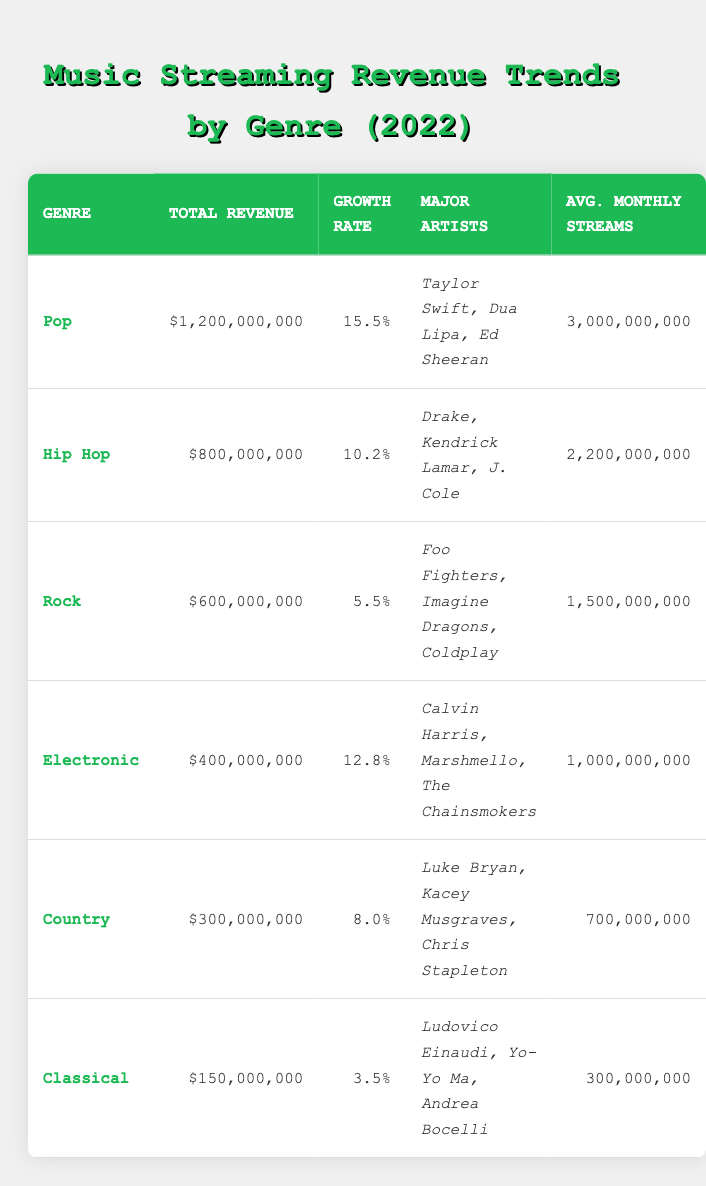What is the total revenue for the Pop genre in 2022? According to the table, the total revenue for the Pop genre is specifically listed as $1,200,000,000.
Answer: $1,200,000,000 Which genre experienced the highest growth rate? The table shows the growth rates for each genre, and Pop has the highest growth rate at 15.5%.
Answer: Pop What is the average monthly streams for the Rock genre? The average monthly streams for the Rock genre, as indicated in the table, is 1,500,000,000.
Answer: 1,500,000,000 What is the total revenue across all genres in 2022? To find the total revenue, we sum the revenues for all listed genres: 1,200,000,000 (Pop) + 800,000,000 (Hip Hop) + 600,000,000 (Rock) + 400,000,000 (Electronic) + 300,000,000 (Country) + 150,000,000 (Classical) = 3,450,000,000.
Answer: $3,450,000,000 Is the growth rate for Electronic music greater than that for Country music? The growth rate for Electronic music is 12.8%, while the growth rate for Country music is 8.0%. Since 12.8% is greater than 8.0%, the statement is true.
Answer: Yes Are the average monthly streams for Classical music higher than for Hip Hop? The average monthly streams for Classical music is 300,000,000, while for Hip Hop it is 2,200,000,000. Since 300,000,000 is not higher, the statement is false.
Answer: No What is the total revenue for genres that have a growth rate of over 10%? The genres with a growth rate over 10% are Pop (15.5%), Hip Hop (10.2%), and Electronic (12.8%). The total revenue is calculated as follows: 1,200,000,000 (Pop) + 800,000,000 (Hip Hop) + 400,000,000 (Electronic) = 2,400,000,000.
Answer: $2,400,000,000 Which genre has the lowest total revenue and what is the amount? By examining the total revenue figures in the table, Classical has the lowest total revenue at $150,000,000.
Answer: Classical, $150,000,000 How many major artists are listed for the Country genre? The table indicates that there are three major artists listed under the Country genre: Luke Bryan, Kacey Musgraves, and Chris Stapleton.
Answer: 3 